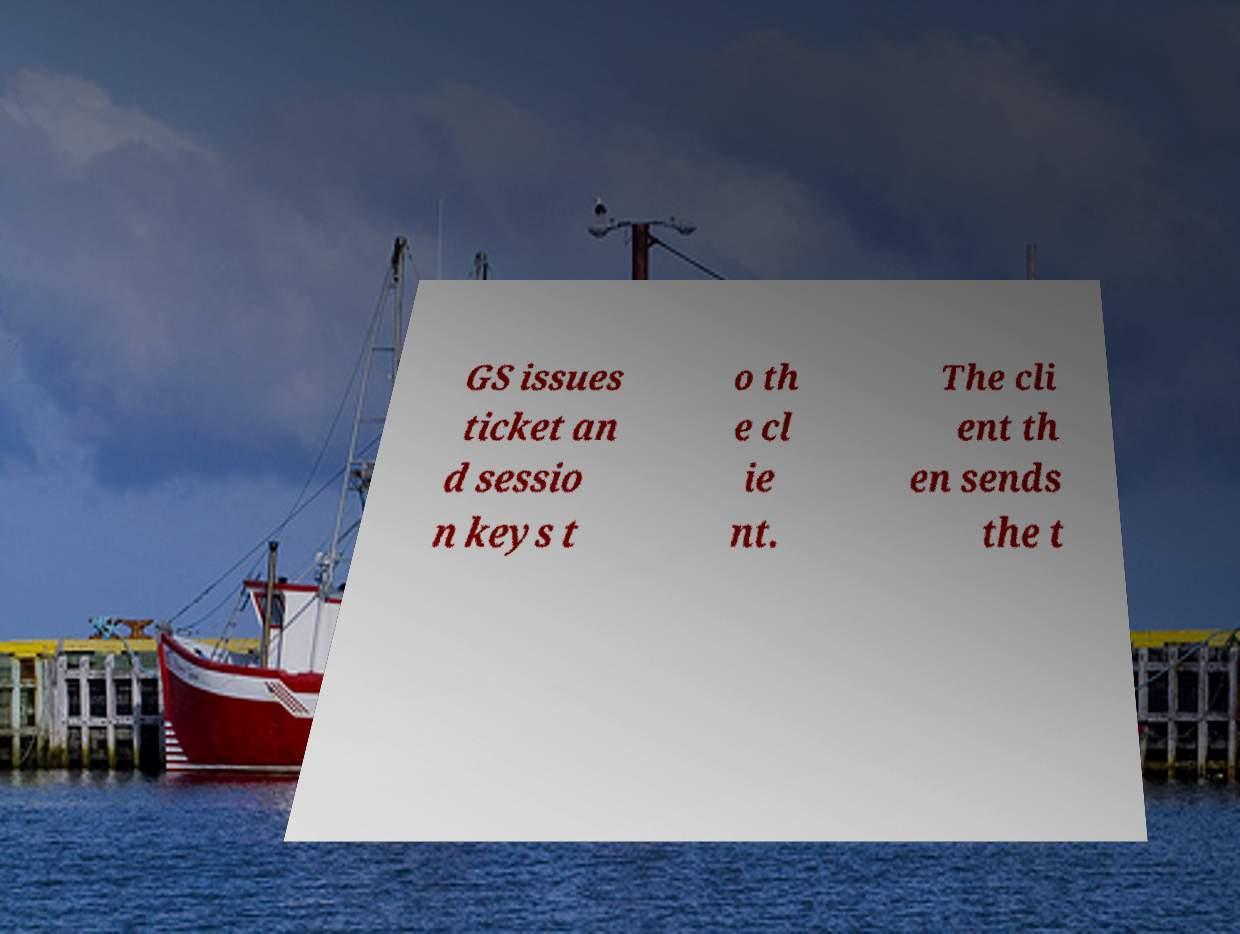For documentation purposes, I need the text within this image transcribed. Could you provide that? GS issues ticket an d sessio n keys t o th e cl ie nt. The cli ent th en sends the t 